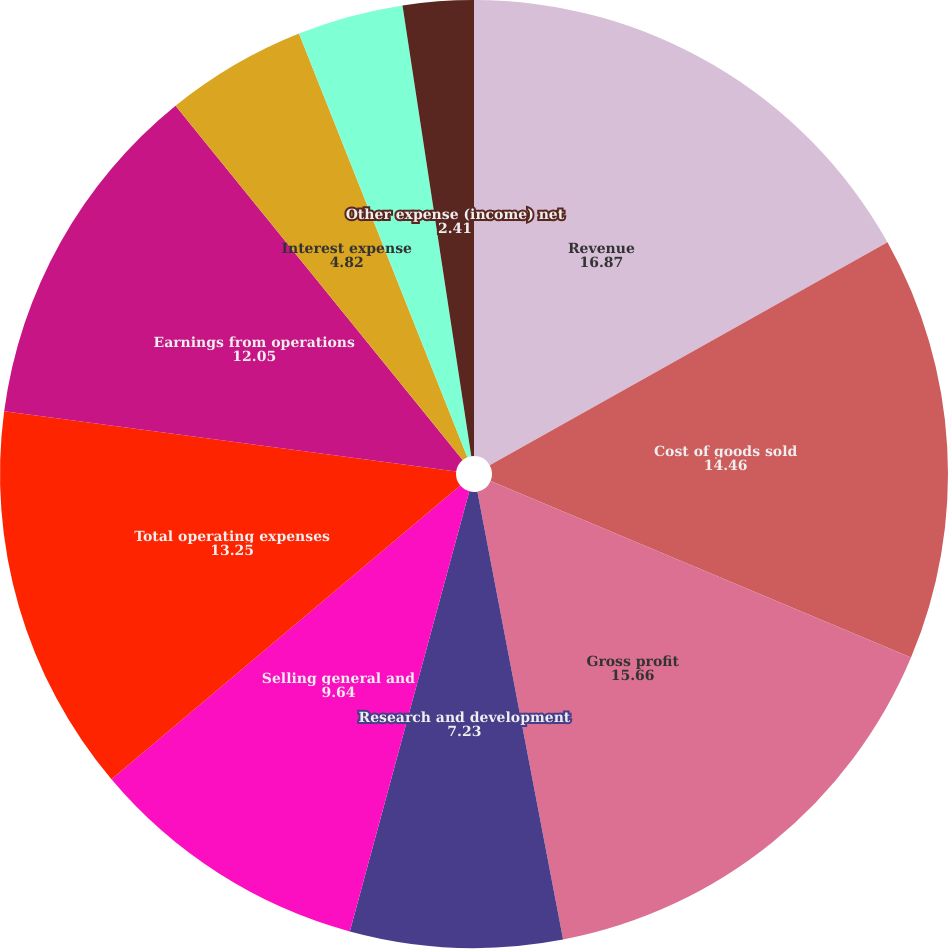Convert chart to OTSL. <chart><loc_0><loc_0><loc_500><loc_500><pie_chart><fcel>Revenue<fcel>Cost of goods sold<fcel>Gross profit<fcel>Research and development<fcel>Selling general and<fcel>Total operating expenses<fcel>Earnings from operations<fcel>Interest expense<fcel>Interest income<fcel>Other expense (income) net<nl><fcel>16.87%<fcel>14.46%<fcel>15.66%<fcel>7.23%<fcel>9.64%<fcel>13.25%<fcel>12.05%<fcel>4.82%<fcel>3.61%<fcel>2.41%<nl></chart> 